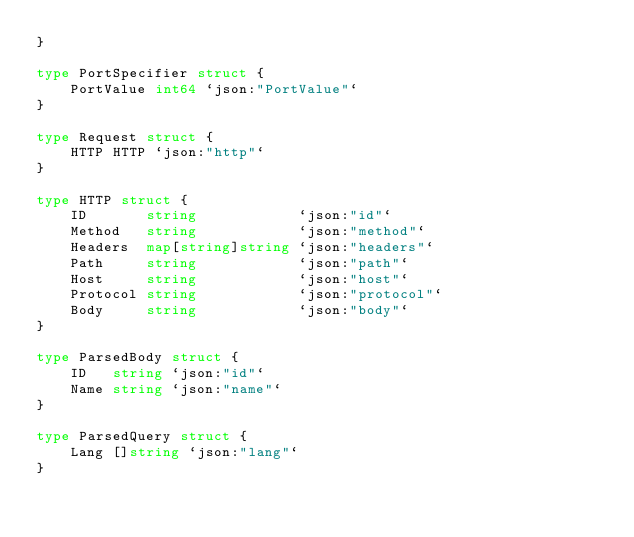Convert code to text. <code><loc_0><loc_0><loc_500><loc_500><_Go_>}

type PortSpecifier struct {
	PortValue int64 `json:"PortValue"`
}

type Request struct {
	HTTP HTTP `json:"http"`
}

type HTTP struct {
	ID       string            `json:"id"`
	Method   string            `json:"method"`
	Headers  map[string]string `json:"headers"`
	Path     string            `json:"path"`
	Host     string            `json:"host"`
	Protocol string            `json:"protocol"`
	Body     string            `json:"body"`
}

type ParsedBody struct {
	ID   string `json:"id"`
	Name string `json:"name"`
}

type ParsedQuery struct {
	Lang []string `json:"lang"`
}
</code> 